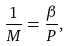<formula> <loc_0><loc_0><loc_500><loc_500>\frac { 1 } { M } = \frac { \beta } { P } ,</formula> 